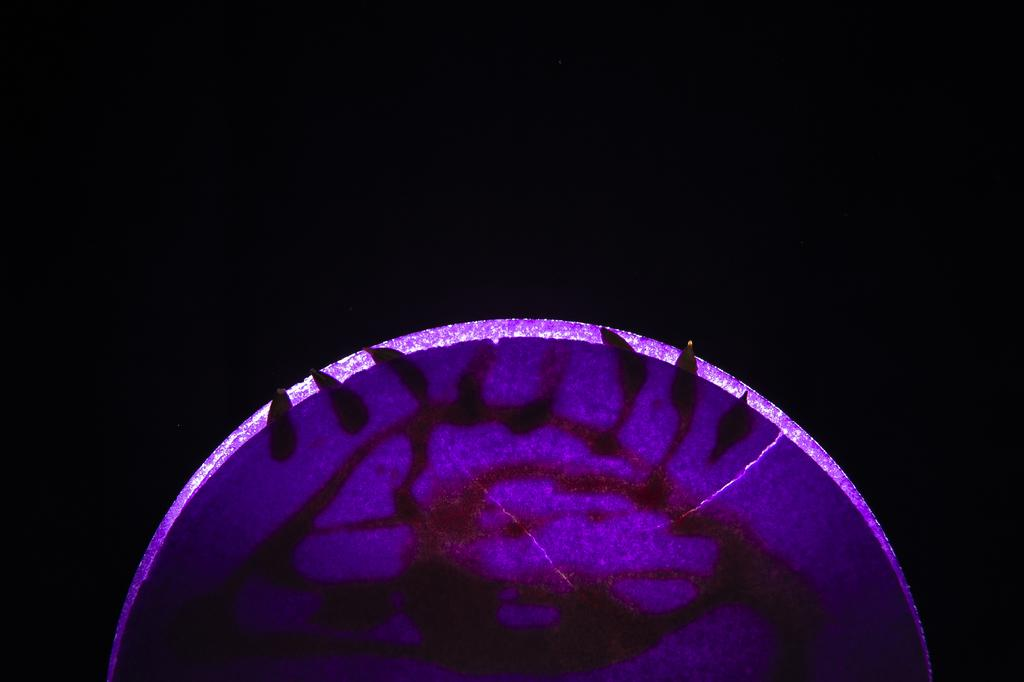What is the color contrast like in the image? The image has both a light background and a dark background. Can you describe the overall appearance of the image based on the background colors? The image has a contrasting appearance due to the presence of both light and dark backgrounds. What type of plant is making a statement in the image? There is no plant present in the image, and therefore no such statement can be made. 